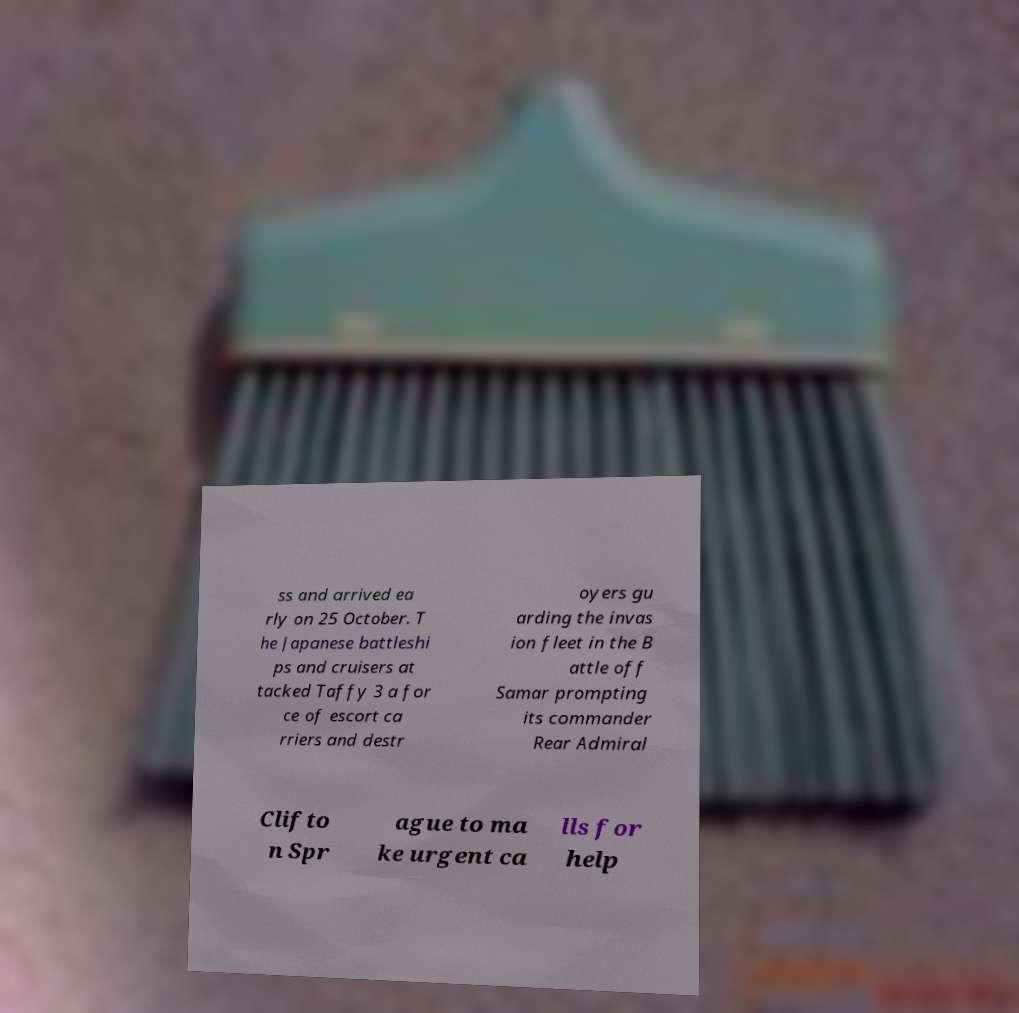Please identify and transcribe the text found in this image. ss and arrived ea rly on 25 October. T he Japanese battleshi ps and cruisers at tacked Taffy 3 a for ce of escort ca rriers and destr oyers gu arding the invas ion fleet in the B attle off Samar prompting its commander Rear Admiral Clifto n Spr ague to ma ke urgent ca lls for help 